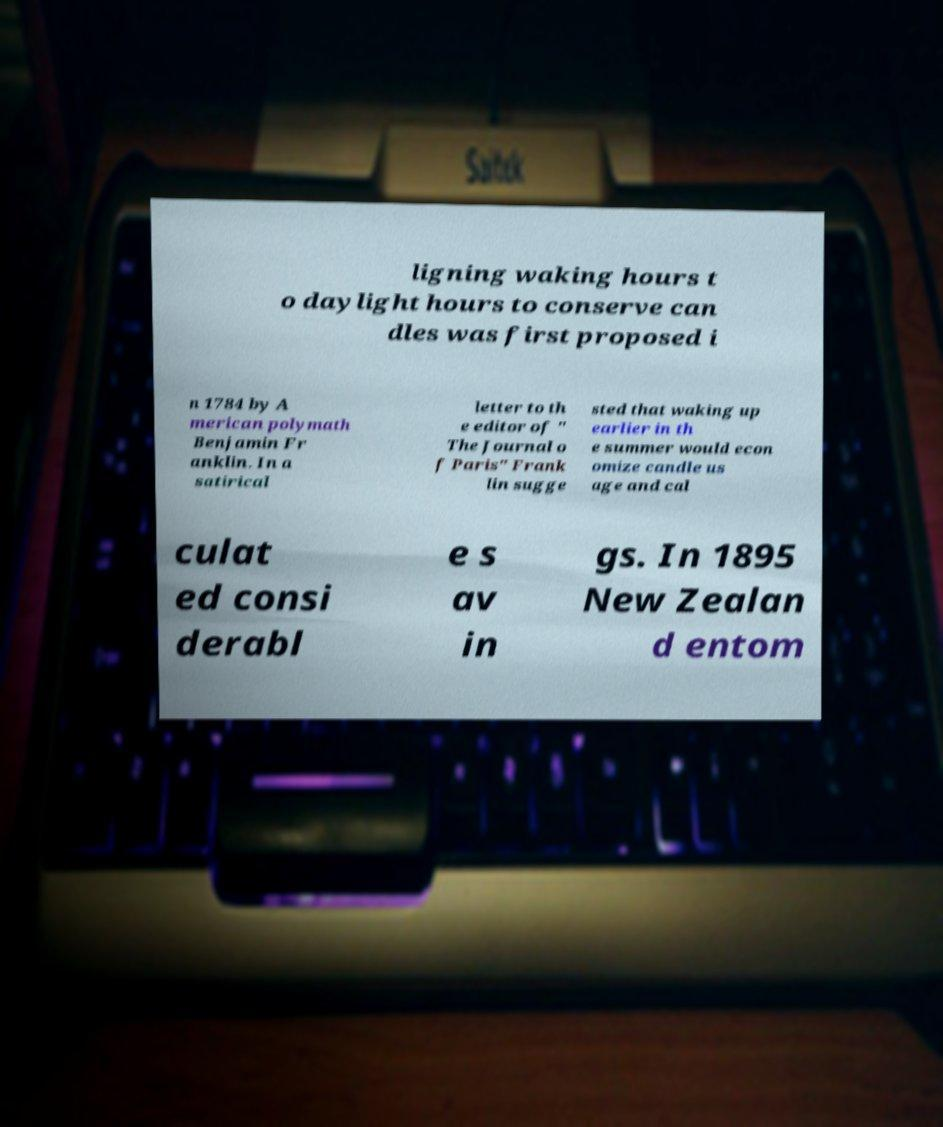Could you extract and type out the text from this image? ligning waking hours t o daylight hours to conserve can dles was first proposed i n 1784 by A merican polymath Benjamin Fr anklin. In a satirical letter to th e editor of " The Journal o f Paris" Frank lin sugge sted that waking up earlier in th e summer would econ omize candle us age and cal culat ed consi derabl e s av in gs. In 1895 New Zealan d entom 